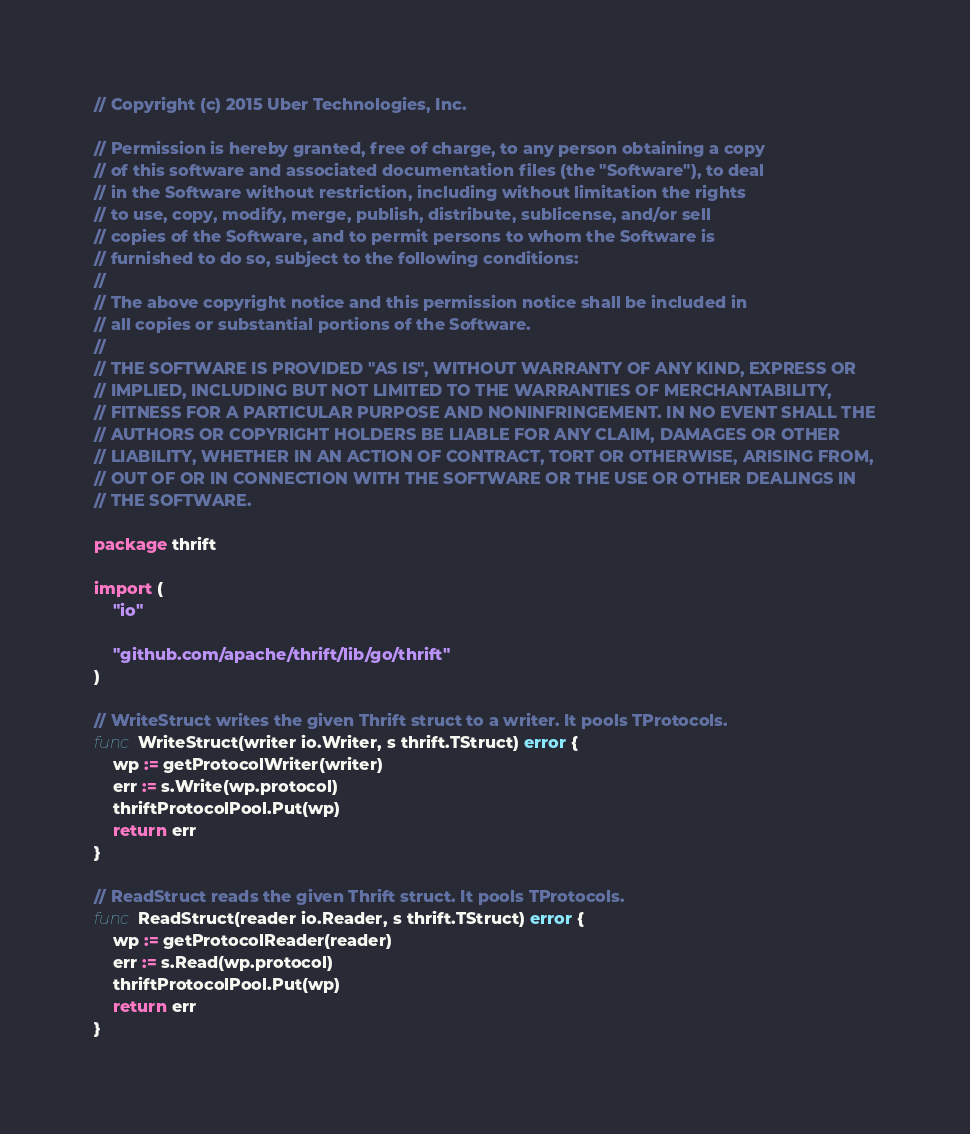Convert code to text. <code><loc_0><loc_0><loc_500><loc_500><_Go_>// Copyright (c) 2015 Uber Technologies, Inc.

// Permission is hereby granted, free of charge, to any person obtaining a copy
// of this software and associated documentation files (the "Software"), to deal
// in the Software without restriction, including without limitation the rights
// to use, copy, modify, merge, publish, distribute, sublicense, and/or sell
// copies of the Software, and to permit persons to whom the Software is
// furnished to do so, subject to the following conditions:
//
// The above copyright notice and this permission notice shall be included in
// all copies or substantial portions of the Software.
//
// THE SOFTWARE IS PROVIDED "AS IS", WITHOUT WARRANTY OF ANY KIND, EXPRESS OR
// IMPLIED, INCLUDING BUT NOT LIMITED TO THE WARRANTIES OF MERCHANTABILITY,
// FITNESS FOR A PARTICULAR PURPOSE AND NONINFRINGEMENT. IN NO EVENT SHALL THE
// AUTHORS OR COPYRIGHT HOLDERS BE LIABLE FOR ANY CLAIM, DAMAGES OR OTHER
// LIABILITY, WHETHER IN AN ACTION OF CONTRACT, TORT OR OTHERWISE, ARISING FROM,
// OUT OF OR IN CONNECTION WITH THE SOFTWARE OR THE USE OR OTHER DEALINGS IN
// THE SOFTWARE.

package thrift

import (
	"io"

	"github.com/apache/thrift/lib/go/thrift"
)

// WriteStruct writes the given Thrift struct to a writer. It pools TProtocols.
func WriteStruct(writer io.Writer, s thrift.TStruct) error {
	wp := getProtocolWriter(writer)
	err := s.Write(wp.protocol)
	thriftProtocolPool.Put(wp)
	return err
}

// ReadStruct reads the given Thrift struct. It pools TProtocols.
func ReadStruct(reader io.Reader, s thrift.TStruct) error {
	wp := getProtocolReader(reader)
	err := s.Read(wp.protocol)
	thriftProtocolPool.Put(wp)
	return err
}
</code> 